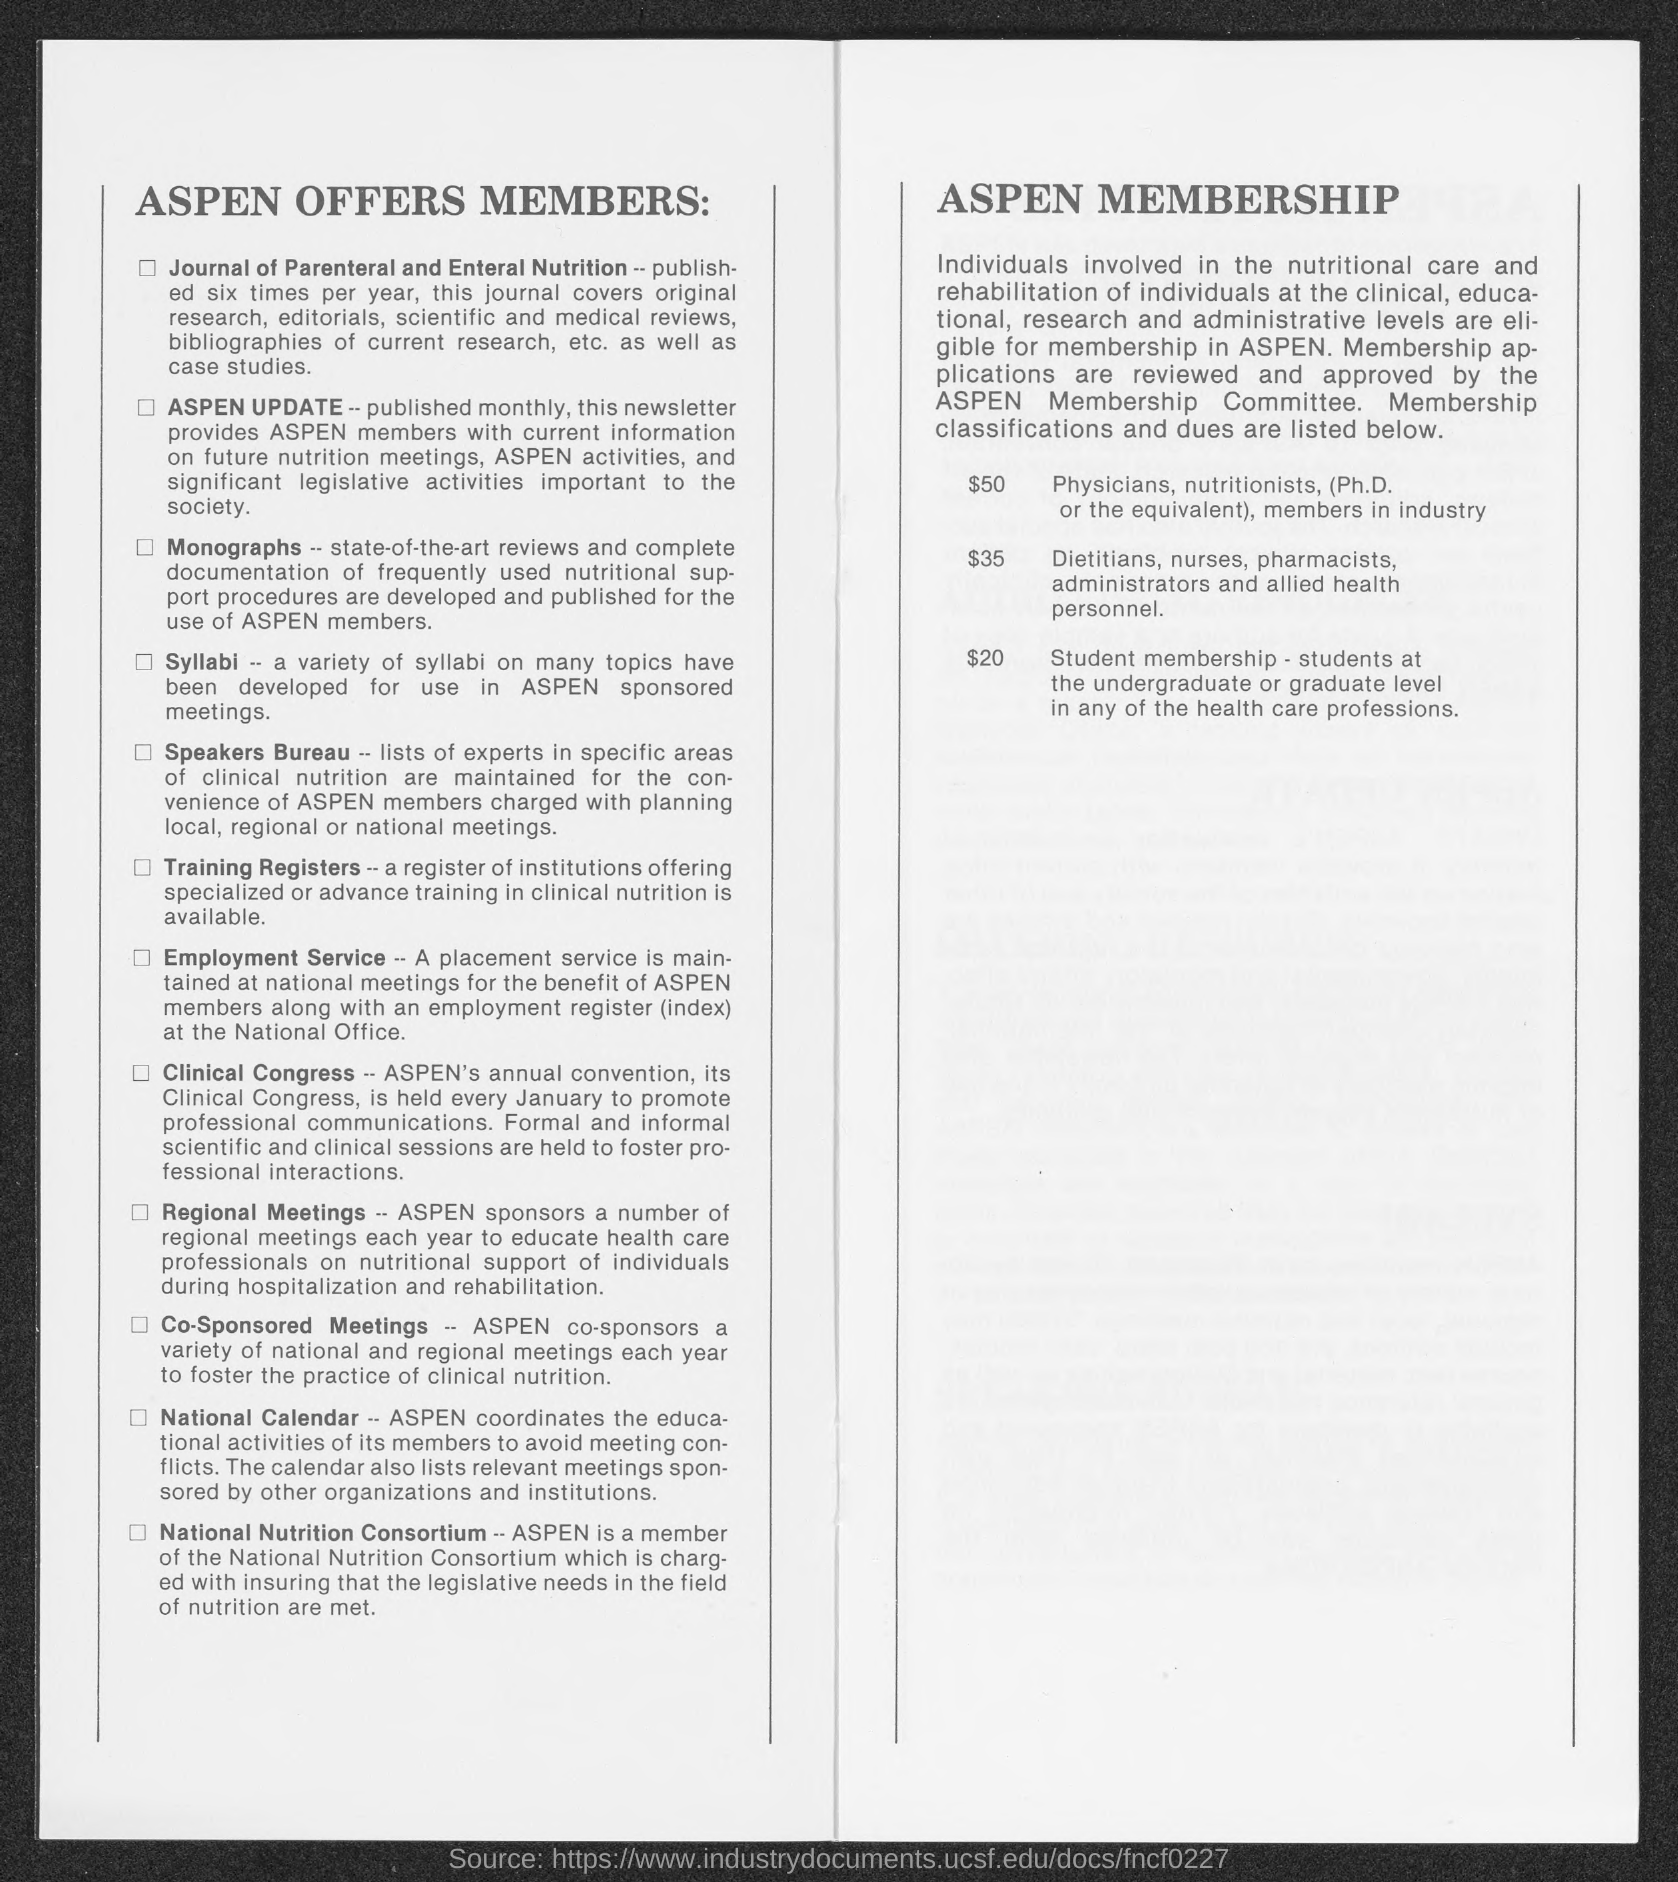How many times a year does the Journal of Parental and Enteral Nutrition is published?
Keep it short and to the point. Six times. 